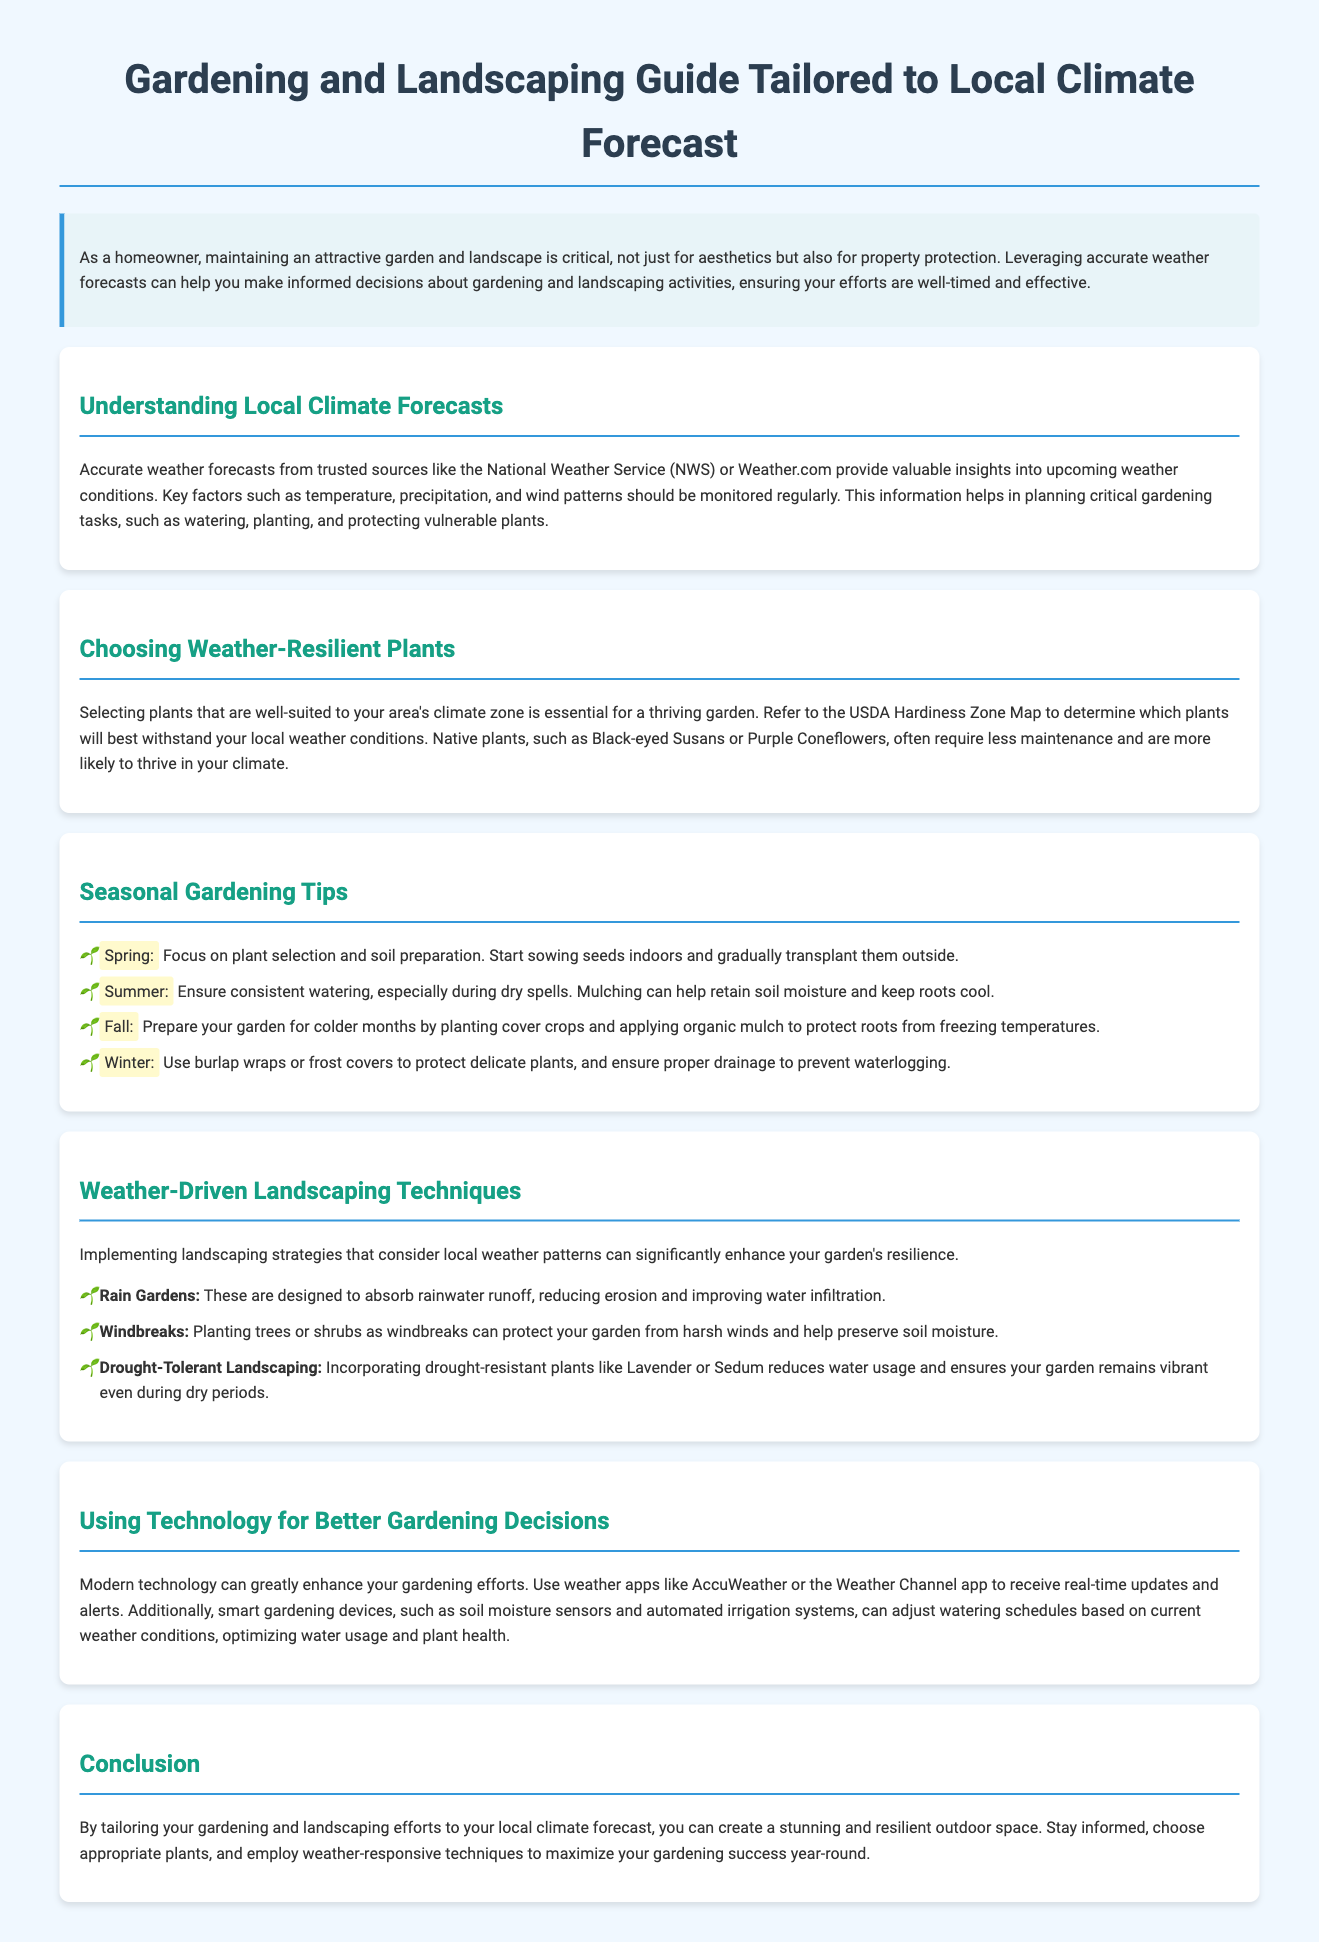What are trusted sources for weather forecasts? The document mentions the National Weather Service (NWS) and Weather.com as trusted sources for weather forecasts.
Answer: National Weather Service (NWS), Weather.com What plants are recommended for drought-tolerant landscaping? The document specifically mentions Lavender and Sedum for drought-tolerant landscaping, highlighting their water conservation benefits.
Answer: Lavender, Sedum What is suggested for spring gardening tasks? The document states that spring is focused on plant selection and soil preparation, along with starting seeds indoors and transplanting them outside.
Answer: Plant selection, soil preparation, sow seeds indoors What is the primary purpose of rain gardens? According to the document, rain gardens are designed to absorb rainwater runoff to reduce erosion and improve water infiltration.
Answer: Absorb rainwater runoff Which season should you use burlap wraps or frost covers? The document specifies that burlap wraps or frost covers should be used in winter to protect delicate plants.
Answer: Winter What technology is recommended for better gardening decisions? The document suggests using weather apps, such as AccuWeather or the Weather Channel app, along with smart gardening devices like soil moisture sensors.
Answer: Weather apps, smart gardening devices How can windbreaks benefit a garden? The document explains that windbreaks, created by planting trees or shrubs, can protect gardens from harsh winds and help preserve soil moisture.
Answer: Protect from harsh winds, preserve soil moisture What does the USDA Hardiness Zone Map assist with? The document indicates that the USDA Hardiness Zone Map helps determine which plants will best withstand local weather conditions.
Answer: Determine suitable plants for local weather conditions 